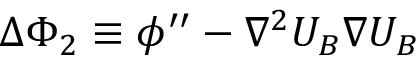Convert formula to latex. <formula><loc_0><loc_0><loc_500><loc_500>\Delta \Phi _ { 2 } \equiv \phi ^ { \prime \prime } - \nabla ^ { 2 } U _ { B } \nabla U _ { B }</formula> 